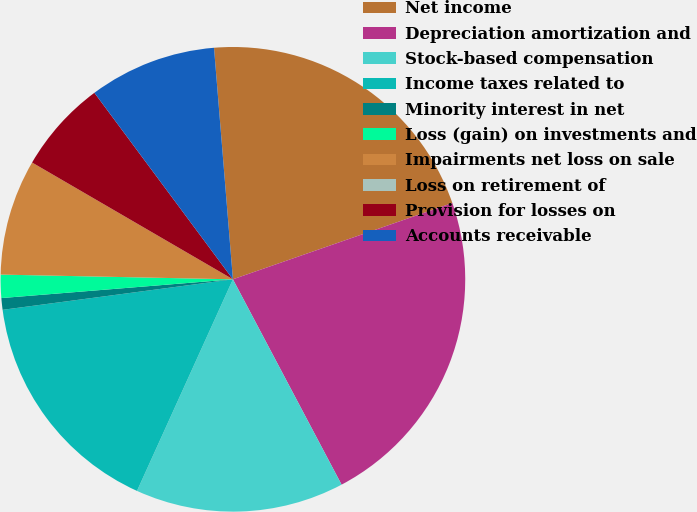<chart> <loc_0><loc_0><loc_500><loc_500><pie_chart><fcel>Net income<fcel>Depreciation amortization and<fcel>Stock-based compensation<fcel>Income taxes related to<fcel>Minority interest in net<fcel>Loss (gain) on investments and<fcel>Impairments net loss on sale<fcel>Loss on retirement of<fcel>Provision for losses on<fcel>Accounts receivable<nl><fcel>20.97%<fcel>22.58%<fcel>14.52%<fcel>16.13%<fcel>0.81%<fcel>1.61%<fcel>8.06%<fcel>0.0%<fcel>6.45%<fcel>8.87%<nl></chart> 